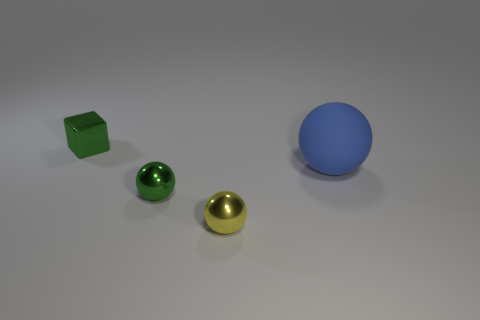What time of day or lighting scenario do the shadows suggest in this scene? The long and soft-edged shadows cast on the ground suggest a source of diffuse light, such as an overcast day or a room with soft artificial lighting, as opposed to harsh sunlight. 